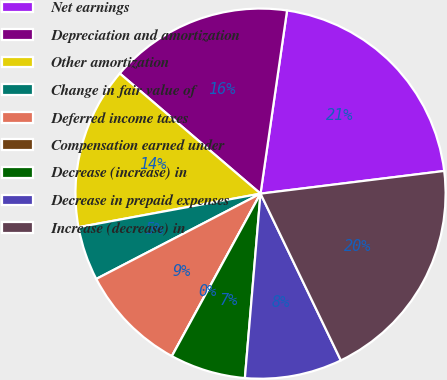<chart> <loc_0><loc_0><loc_500><loc_500><pie_chart><fcel>Net earnings<fcel>Depreciation and amortization<fcel>Other amortization<fcel>Change in fair value of<fcel>Deferred income taxes<fcel>Compensation earned under<fcel>Decrease (increase) in<fcel>Decrease in prepaid expenses<fcel>Increase (decrease) in<nl><fcel>20.75%<fcel>16.04%<fcel>14.15%<fcel>4.72%<fcel>9.43%<fcel>0.0%<fcel>6.6%<fcel>8.49%<fcel>19.81%<nl></chart> 